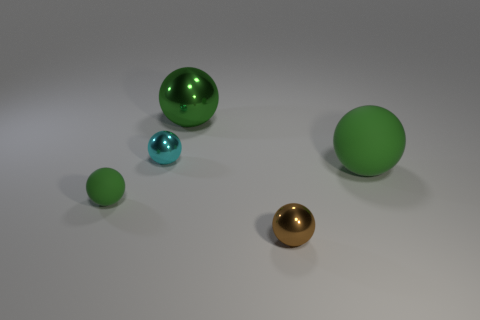Subtract all red cylinders. How many green spheres are left? 3 Subtract all brown balls. How many balls are left? 4 Subtract all large green matte balls. How many balls are left? 4 Subtract all blue spheres. Subtract all yellow cylinders. How many spheres are left? 5 Add 3 tiny red shiny blocks. How many objects exist? 8 Add 2 large objects. How many large objects exist? 4 Subtract 0 cyan blocks. How many objects are left? 5 Subtract all metal objects. Subtract all cyan metallic balls. How many objects are left? 1 Add 4 big matte spheres. How many big matte spheres are left? 5 